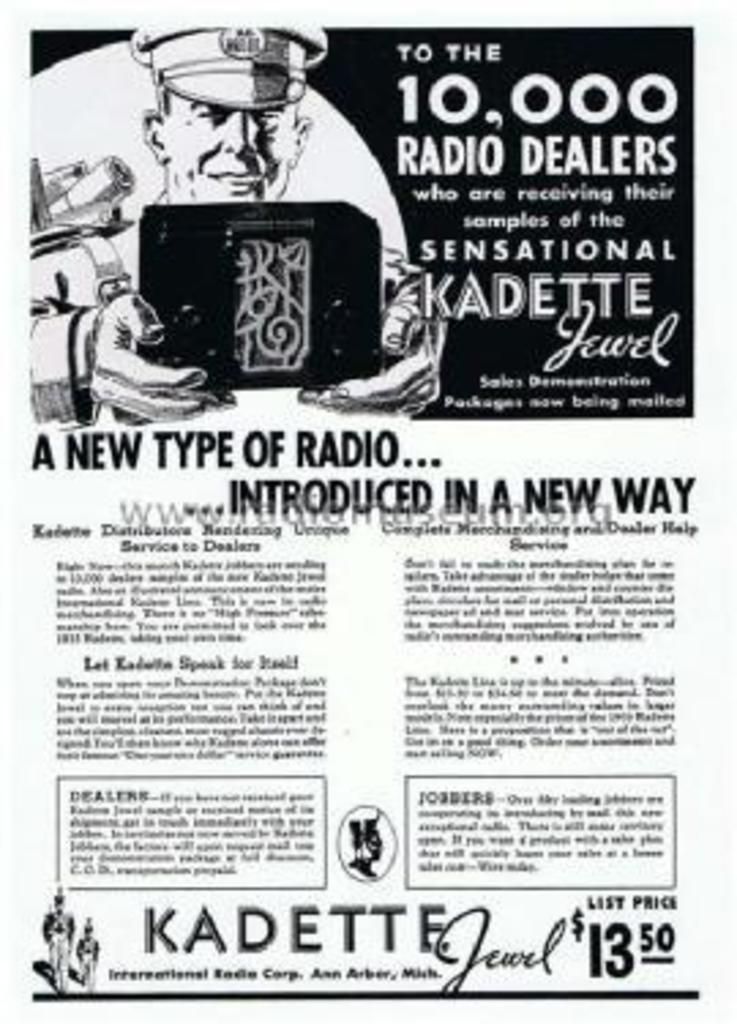<image>
Give a short and clear explanation of the subsequent image. a paper that says 'a new type of radio... introduced in a new way' on it 